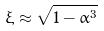Convert formula to latex. <formula><loc_0><loc_0><loc_500><loc_500>\xi \approx \sqrt { 1 - \alpha ^ { 3 } }</formula> 